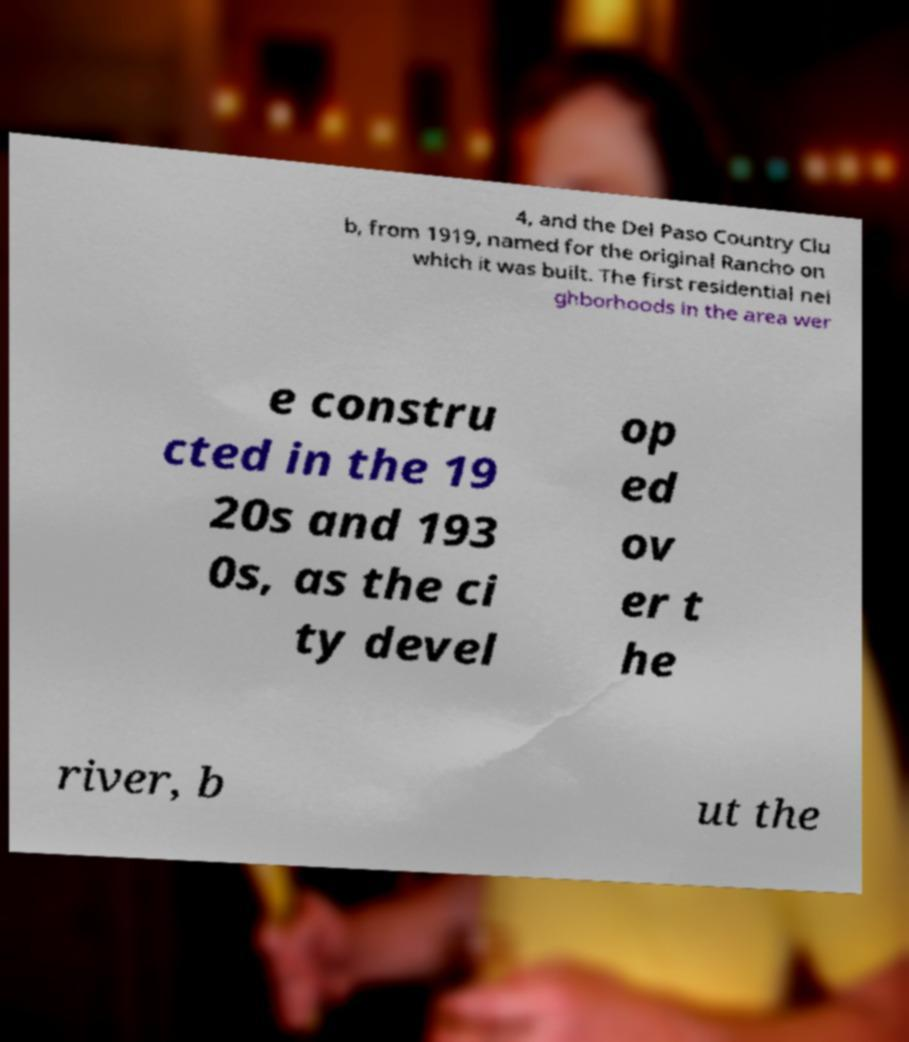Please identify and transcribe the text found in this image. 4, and the Del Paso Country Clu b, from 1919, named for the original Rancho on which it was built. The first residential nei ghborhoods in the area wer e constru cted in the 19 20s and 193 0s, as the ci ty devel op ed ov er t he river, b ut the 